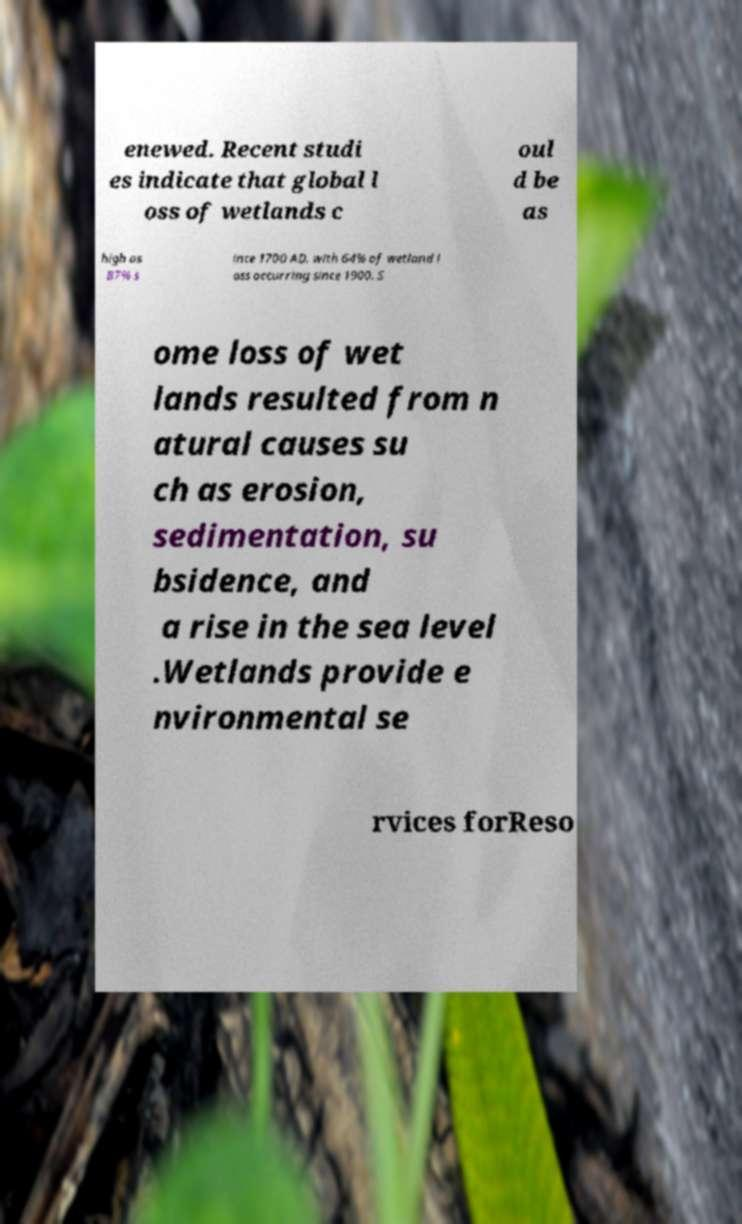Can you accurately transcribe the text from the provided image for me? enewed. Recent studi es indicate that global l oss of wetlands c oul d be as high as 87% s ince 1700 AD, with 64% of wetland l oss occurring since 1900. S ome loss of wet lands resulted from n atural causes su ch as erosion, sedimentation, su bsidence, and a rise in the sea level .Wetlands provide e nvironmental se rvices forReso 